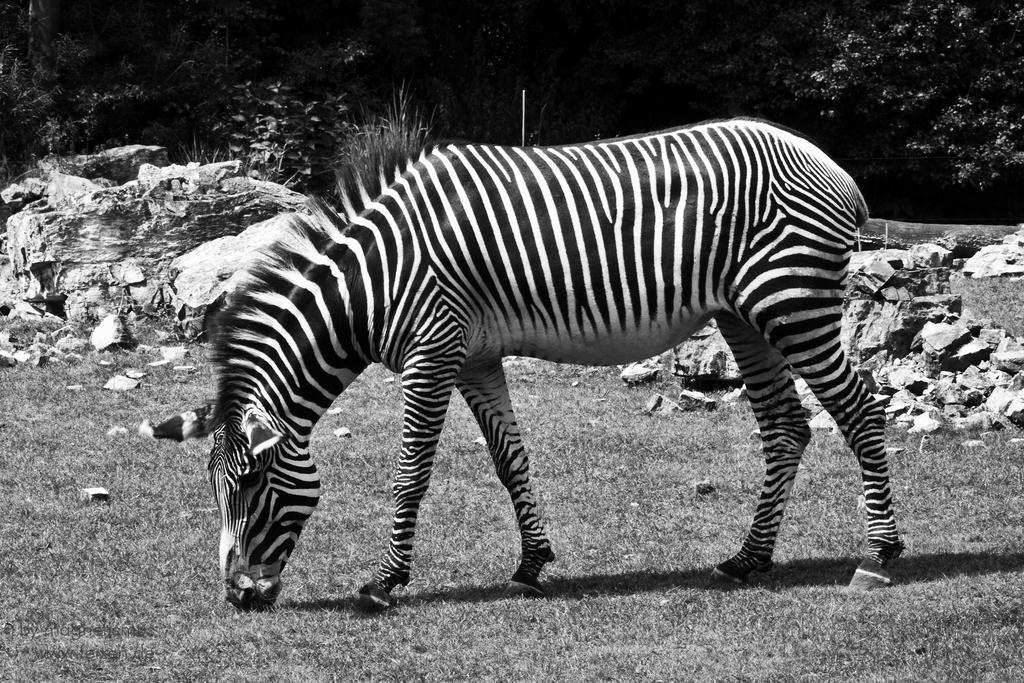Describe this image in one or two sentences. In this picture I can see a zebra grazing grass and I can see few rocks and trees in the background. 